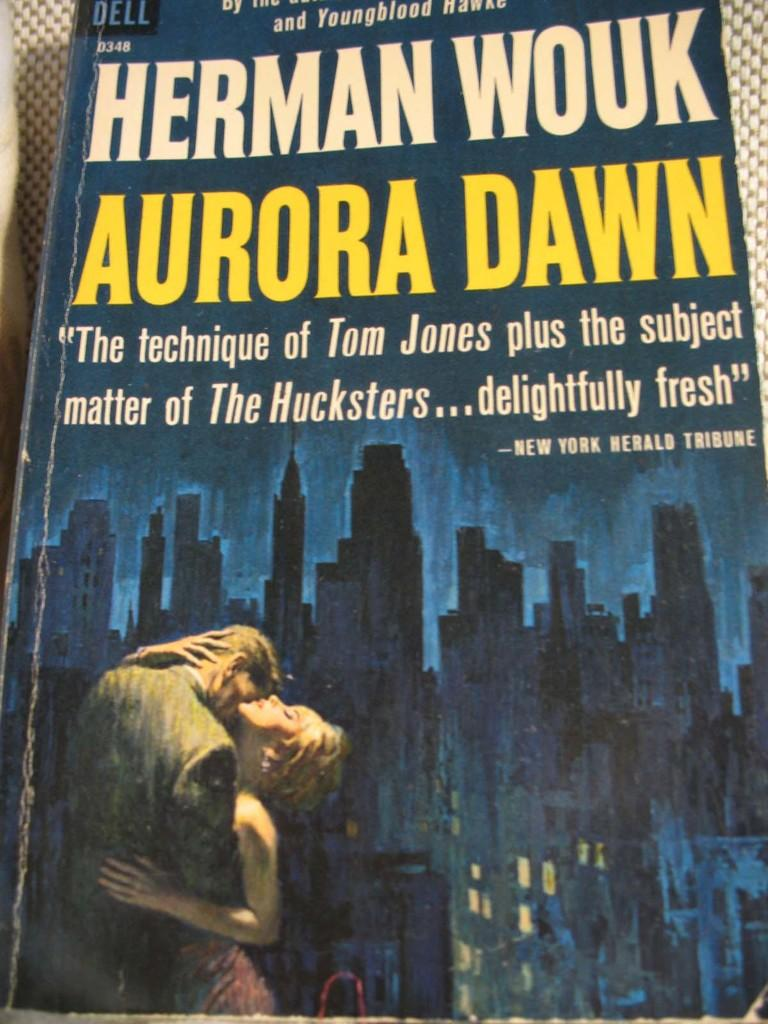<image>
Write a terse but informative summary of the picture. Herman Wouk's Aurora Dawn has a review by the New York Herald Tribune on its cover. 